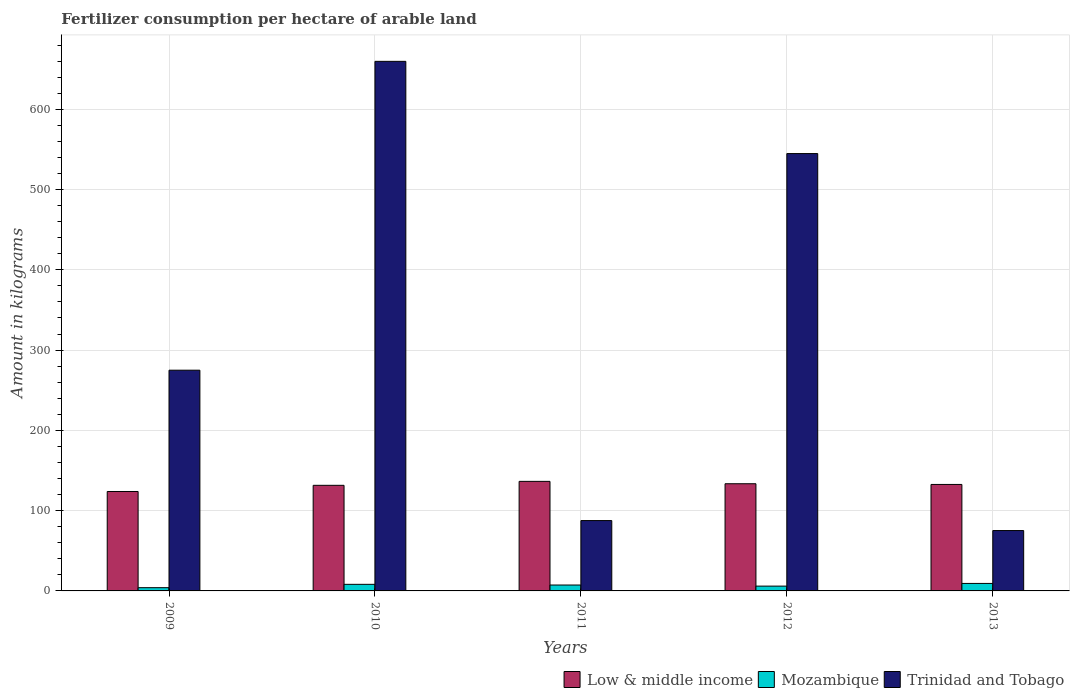How many groups of bars are there?
Provide a succinct answer. 5. Are the number of bars per tick equal to the number of legend labels?
Provide a succinct answer. Yes. Are the number of bars on each tick of the X-axis equal?
Offer a terse response. Yes. How many bars are there on the 5th tick from the left?
Give a very brief answer. 3. What is the label of the 5th group of bars from the left?
Keep it short and to the point. 2013. In how many cases, is the number of bars for a given year not equal to the number of legend labels?
Give a very brief answer. 0. What is the amount of fertilizer consumption in Mozambique in 2010?
Provide a succinct answer. 8.2. Across all years, what is the maximum amount of fertilizer consumption in Trinidad and Tobago?
Make the answer very short. 659.68. Across all years, what is the minimum amount of fertilizer consumption in Low & middle income?
Keep it short and to the point. 123.85. In which year was the amount of fertilizer consumption in Trinidad and Tobago maximum?
Your answer should be very brief. 2010. What is the total amount of fertilizer consumption in Trinidad and Tobago in the graph?
Your response must be concise. 1642.28. What is the difference between the amount of fertilizer consumption in Low & middle income in 2010 and that in 2013?
Your answer should be compact. -1.08. What is the difference between the amount of fertilizer consumption in Low & middle income in 2010 and the amount of fertilizer consumption in Trinidad and Tobago in 2013?
Your answer should be very brief. 56.35. What is the average amount of fertilizer consumption in Trinidad and Tobago per year?
Offer a very short reply. 328.46. In the year 2013, what is the difference between the amount of fertilizer consumption in Low & middle income and amount of fertilizer consumption in Mozambique?
Provide a succinct answer. 123.31. What is the ratio of the amount of fertilizer consumption in Low & middle income in 2009 to that in 2011?
Your response must be concise. 0.91. Is the amount of fertilizer consumption in Mozambique in 2009 less than that in 2012?
Provide a succinct answer. Yes. What is the difference between the highest and the second highest amount of fertilizer consumption in Low & middle income?
Offer a very short reply. 2.95. What is the difference between the highest and the lowest amount of fertilizer consumption in Low & middle income?
Your answer should be very brief. 12.62. In how many years, is the amount of fertilizer consumption in Low & middle income greater than the average amount of fertilizer consumption in Low & middle income taken over all years?
Provide a short and direct response. 3. Is the sum of the amount of fertilizer consumption in Trinidad and Tobago in 2010 and 2013 greater than the maximum amount of fertilizer consumption in Low & middle income across all years?
Your answer should be very brief. Yes. What does the 2nd bar from the left in 2012 represents?
Ensure brevity in your answer.  Mozambique. What does the 1st bar from the right in 2009 represents?
Your answer should be compact. Trinidad and Tobago. Is it the case that in every year, the sum of the amount of fertilizer consumption in Trinidad and Tobago and amount of fertilizer consumption in Low & middle income is greater than the amount of fertilizer consumption in Mozambique?
Keep it short and to the point. Yes. Are all the bars in the graph horizontal?
Offer a very short reply. No. What is the difference between two consecutive major ticks on the Y-axis?
Offer a very short reply. 100. Are the values on the major ticks of Y-axis written in scientific E-notation?
Offer a terse response. No. What is the title of the graph?
Offer a very short reply. Fertilizer consumption per hectare of arable land. Does "Australia" appear as one of the legend labels in the graph?
Provide a short and direct response. No. What is the label or title of the X-axis?
Ensure brevity in your answer.  Years. What is the label or title of the Y-axis?
Your answer should be compact. Amount in kilograms. What is the Amount in kilograms in Low & middle income in 2009?
Provide a succinct answer. 123.85. What is the Amount in kilograms of Mozambique in 2009?
Provide a succinct answer. 4.03. What is the Amount in kilograms of Trinidad and Tobago in 2009?
Give a very brief answer. 274.96. What is the Amount in kilograms in Low & middle income in 2010?
Keep it short and to the point. 131.55. What is the Amount in kilograms of Mozambique in 2010?
Provide a succinct answer. 8.2. What is the Amount in kilograms of Trinidad and Tobago in 2010?
Keep it short and to the point. 659.68. What is the Amount in kilograms in Low & middle income in 2011?
Your response must be concise. 136.47. What is the Amount in kilograms of Mozambique in 2011?
Give a very brief answer. 7.36. What is the Amount in kilograms in Trinidad and Tobago in 2011?
Offer a terse response. 87.64. What is the Amount in kilograms in Low & middle income in 2012?
Offer a terse response. 133.52. What is the Amount in kilograms of Mozambique in 2012?
Keep it short and to the point. 5.99. What is the Amount in kilograms of Trinidad and Tobago in 2012?
Offer a very short reply. 544.8. What is the Amount in kilograms of Low & middle income in 2013?
Your answer should be very brief. 132.63. What is the Amount in kilograms in Mozambique in 2013?
Your answer should be compact. 9.32. What is the Amount in kilograms of Trinidad and Tobago in 2013?
Your answer should be very brief. 75.2. Across all years, what is the maximum Amount in kilograms of Low & middle income?
Provide a short and direct response. 136.47. Across all years, what is the maximum Amount in kilograms in Mozambique?
Your answer should be compact. 9.32. Across all years, what is the maximum Amount in kilograms in Trinidad and Tobago?
Provide a short and direct response. 659.68. Across all years, what is the minimum Amount in kilograms in Low & middle income?
Your answer should be compact. 123.85. Across all years, what is the minimum Amount in kilograms in Mozambique?
Give a very brief answer. 4.03. Across all years, what is the minimum Amount in kilograms in Trinidad and Tobago?
Make the answer very short. 75.2. What is the total Amount in kilograms in Low & middle income in the graph?
Make the answer very short. 658.03. What is the total Amount in kilograms in Mozambique in the graph?
Offer a terse response. 34.91. What is the total Amount in kilograms in Trinidad and Tobago in the graph?
Ensure brevity in your answer.  1642.28. What is the difference between the Amount in kilograms in Low & middle income in 2009 and that in 2010?
Your answer should be very brief. -7.7. What is the difference between the Amount in kilograms of Mozambique in 2009 and that in 2010?
Make the answer very short. -4.17. What is the difference between the Amount in kilograms in Trinidad and Tobago in 2009 and that in 2010?
Your answer should be compact. -384.72. What is the difference between the Amount in kilograms of Low & middle income in 2009 and that in 2011?
Give a very brief answer. -12.62. What is the difference between the Amount in kilograms of Mozambique in 2009 and that in 2011?
Give a very brief answer. -3.32. What is the difference between the Amount in kilograms of Trinidad and Tobago in 2009 and that in 2011?
Offer a terse response. 187.32. What is the difference between the Amount in kilograms of Low & middle income in 2009 and that in 2012?
Provide a short and direct response. -9.66. What is the difference between the Amount in kilograms in Mozambique in 2009 and that in 2012?
Ensure brevity in your answer.  -1.96. What is the difference between the Amount in kilograms in Trinidad and Tobago in 2009 and that in 2012?
Your answer should be very brief. -269.84. What is the difference between the Amount in kilograms in Low & middle income in 2009 and that in 2013?
Your answer should be very brief. -8.78. What is the difference between the Amount in kilograms in Mozambique in 2009 and that in 2013?
Offer a terse response. -5.29. What is the difference between the Amount in kilograms of Trinidad and Tobago in 2009 and that in 2013?
Make the answer very short. 199.76. What is the difference between the Amount in kilograms of Low & middle income in 2010 and that in 2011?
Offer a terse response. -4.92. What is the difference between the Amount in kilograms of Mozambique in 2010 and that in 2011?
Provide a short and direct response. 0.84. What is the difference between the Amount in kilograms in Trinidad and Tobago in 2010 and that in 2011?
Your response must be concise. 572.04. What is the difference between the Amount in kilograms in Low & middle income in 2010 and that in 2012?
Provide a short and direct response. -1.97. What is the difference between the Amount in kilograms of Mozambique in 2010 and that in 2012?
Offer a terse response. 2.21. What is the difference between the Amount in kilograms of Trinidad and Tobago in 2010 and that in 2012?
Provide a short and direct response. 114.88. What is the difference between the Amount in kilograms in Low & middle income in 2010 and that in 2013?
Provide a succinct answer. -1.08. What is the difference between the Amount in kilograms of Mozambique in 2010 and that in 2013?
Provide a succinct answer. -1.12. What is the difference between the Amount in kilograms of Trinidad and Tobago in 2010 and that in 2013?
Your answer should be very brief. 584.48. What is the difference between the Amount in kilograms of Low & middle income in 2011 and that in 2012?
Offer a very short reply. 2.95. What is the difference between the Amount in kilograms of Mozambique in 2011 and that in 2012?
Make the answer very short. 1.36. What is the difference between the Amount in kilograms of Trinidad and Tobago in 2011 and that in 2012?
Your answer should be very brief. -457.16. What is the difference between the Amount in kilograms of Low & middle income in 2011 and that in 2013?
Provide a succinct answer. 3.84. What is the difference between the Amount in kilograms in Mozambique in 2011 and that in 2013?
Keep it short and to the point. -1.97. What is the difference between the Amount in kilograms in Trinidad and Tobago in 2011 and that in 2013?
Provide a short and direct response. 12.44. What is the difference between the Amount in kilograms of Low & middle income in 2012 and that in 2013?
Your answer should be very brief. 0.88. What is the difference between the Amount in kilograms of Mozambique in 2012 and that in 2013?
Provide a succinct answer. -3.33. What is the difference between the Amount in kilograms of Trinidad and Tobago in 2012 and that in 2013?
Your response must be concise. 469.6. What is the difference between the Amount in kilograms of Low & middle income in 2009 and the Amount in kilograms of Mozambique in 2010?
Provide a short and direct response. 115.66. What is the difference between the Amount in kilograms in Low & middle income in 2009 and the Amount in kilograms in Trinidad and Tobago in 2010?
Offer a terse response. -535.83. What is the difference between the Amount in kilograms in Mozambique in 2009 and the Amount in kilograms in Trinidad and Tobago in 2010?
Your answer should be compact. -655.65. What is the difference between the Amount in kilograms in Low & middle income in 2009 and the Amount in kilograms in Mozambique in 2011?
Keep it short and to the point. 116.5. What is the difference between the Amount in kilograms in Low & middle income in 2009 and the Amount in kilograms in Trinidad and Tobago in 2011?
Provide a succinct answer. 36.21. What is the difference between the Amount in kilograms of Mozambique in 2009 and the Amount in kilograms of Trinidad and Tobago in 2011?
Keep it short and to the point. -83.61. What is the difference between the Amount in kilograms in Low & middle income in 2009 and the Amount in kilograms in Mozambique in 2012?
Offer a very short reply. 117.86. What is the difference between the Amount in kilograms of Low & middle income in 2009 and the Amount in kilograms of Trinidad and Tobago in 2012?
Offer a very short reply. -420.95. What is the difference between the Amount in kilograms of Mozambique in 2009 and the Amount in kilograms of Trinidad and Tobago in 2012?
Make the answer very short. -540.77. What is the difference between the Amount in kilograms in Low & middle income in 2009 and the Amount in kilograms in Mozambique in 2013?
Provide a succinct answer. 114.53. What is the difference between the Amount in kilograms in Low & middle income in 2009 and the Amount in kilograms in Trinidad and Tobago in 2013?
Provide a succinct answer. 48.65. What is the difference between the Amount in kilograms of Mozambique in 2009 and the Amount in kilograms of Trinidad and Tobago in 2013?
Offer a terse response. -71.17. What is the difference between the Amount in kilograms in Low & middle income in 2010 and the Amount in kilograms in Mozambique in 2011?
Offer a terse response. 124.19. What is the difference between the Amount in kilograms in Low & middle income in 2010 and the Amount in kilograms in Trinidad and Tobago in 2011?
Offer a very short reply. 43.91. What is the difference between the Amount in kilograms of Mozambique in 2010 and the Amount in kilograms of Trinidad and Tobago in 2011?
Your response must be concise. -79.44. What is the difference between the Amount in kilograms in Low & middle income in 2010 and the Amount in kilograms in Mozambique in 2012?
Your answer should be compact. 125.56. What is the difference between the Amount in kilograms of Low & middle income in 2010 and the Amount in kilograms of Trinidad and Tobago in 2012?
Provide a succinct answer. -413.25. What is the difference between the Amount in kilograms in Mozambique in 2010 and the Amount in kilograms in Trinidad and Tobago in 2012?
Give a very brief answer. -536.6. What is the difference between the Amount in kilograms of Low & middle income in 2010 and the Amount in kilograms of Mozambique in 2013?
Keep it short and to the point. 122.23. What is the difference between the Amount in kilograms of Low & middle income in 2010 and the Amount in kilograms of Trinidad and Tobago in 2013?
Give a very brief answer. 56.35. What is the difference between the Amount in kilograms in Mozambique in 2010 and the Amount in kilograms in Trinidad and Tobago in 2013?
Make the answer very short. -67. What is the difference between the Amount in kilograms of Low & middle income in 2011 and the Amount in kilograms of Mozambique in 2012?
Ensure brevity in your answer.  130.48. What is the difference between the Amount in kilograms of Low & middle income in 2011 and the Amount in kilograms of Trinidad and Tobago in 2012?
Provide a short and direct response. -408.33. What is the difference between the Amount in kilograms of Mozambique in 2011 and the Amount in kilograms of Trinidad and Tobago in 2012?
Make the answer very short. -537.44. What is the difference between the Amount in kilograms of Low & middle income in 2011 and the Amount in kilograms of Mozambique in 2013?
Offer a very short reply. 127.15. What is the difference between the Amount in kilograms of Low & middle income in 2011 and the Amount in kilograms of Trinidad and Tobago in 2013?
Your response must be concise. 61.27. What is the difference between the Amount in kilograms in Mozambique in 2011 and the Amount in kilograms in Trinidad and Tobago in 2013?
Offer a terse response. -67.84. What is the difference between the Amount in kilograms in Low & middle income in 2012 and the Amount in kilograms in Mozambique in 2013?
Offer a very short reply. 124.2. What is the difference between the Amount in kilograms of Low & middle income in 2012 and the Amount in kilograms of Trinidad and Tobago in 2013?
Make the answer very short. 58.32. What is the difference between the Amount in kilograms of Mozambique in 2012 and the Amount in kilograms of Trinidad and Tobago in 2013?
Make the answer very short. -69.21. What is the average Amount in kilograms in Low & middle income per year?
Keep it short and to the point. 131.61. What is the average Amount in kilograms of Mozambique per year?
Offer a terse response. 6.98. What is the average Amount in kilograms in Trinidad and Tobago per year?
Provide a short and direct response. 328.46. In the year 2009, what is the difference between the Amount in kilograms in Low & middle income and Amount in kilograms in Mozambique?
Provide a short and direct response. 119.82. In the year 2009, what is the difference between the Amount in kilograms in Low & middle income and Amount in kilograms in Trinidad and Tobago?
Ensure brevity in your answer.  -151.11. In the year 2009, what is the difference between the Amount in kilograms of Mozambique and Amount in kilograms of Trinidad and Tobago?
Your answer should be very brief. -270.93. In the year 2010, what is the difference between the Amount in kilograms of Low & middle income and Amount in kilograms of Mozambique?
Ensure brevity in your answer.  123.35. In the year 2010, what is the difference between the Amount in kilograms in Low & middle income and Amount in kilograms in Trinidad and Tobago?
Your response must be concise. -528.13. In the year 2010, what is the difference between the Amount in kilograms in Mozambique and Amount in kilograms in Trinidad and Tobago?
Provide a succinct answer. -651.48. In the year 2011, what is the difference between the Amount in kilograms in Low & middle income and Amount in kilograms in Mozambique?
Give a very brief answer. 129.12. In the year 2011, what is the difference between the Amount in kilograms of Low & middle income and Amount in kilograms of Trinidad and Tobago?
Your response must be concise. 48.83. In the year 2011, what is the difference between the Amount in kilograms of Mozambique and Amount in kilograms of Trinidad and Tobago?
Provide a short and direct response. -80.28. In the year 2012, what is the difference between the Amount in kilograms of Low & middle income and Amount in kilograms of Mozambique?
Your answer should be very brief. 127.53. In the year 2012, what is the difference between the Amount in kilograms of Low & middle income and Amount in kilograms of Trinidad and Tobago?
Keep it short and to the point. -411.28. In the year 2012, what is the difference between the Amount in kilograms in Mozambique and Amount in kilograms in Trinidad and Tobago?
Keep it short and to the point. -538.81. In the year 2013, what is the difference between the Amount in kilograms in Low & middle income and Amount in kilograms in Mozambique?
Your answer should be compact. 123.31. In the year 2013, what is the difference between the Amount in kilograms in Low & middle income and Amount in kilograms in Trinidad and Tobago?
Offer a very short reply. 57.43. In the year 2013, what is the difference between the Amount in kilograms of Mozambique and Amount in kilograms of Trinidad and Tobago?
Offer a terse response. -65.88. What is the ratio of the Amount in kilograms in Low & middle income in 2009 to that in 2010?
Your response must be concise. 0.94. What is the ratio of the Amount in kilograms of Mozambique in 2009 to that in 2010?
Ensure brevity in your answer.  0.49. What is the ratio of the Amount in kilograms in Trinidad and Tobago in 2009 to that in 2010?
Your response must be concise. 0.42. What is the ratio of the Amount in kilograms in Low & middle income in 2009 to that in 2011?
Ensure brevity in your answer.  0.91. What is the ratio of the Amount in kilograms of Mozambique in 2009 to that in 2011?
Provide a succinct answer. 0.55. What is the ratio of the Amount in kilograms in Trinidad and Tobago in 2009 to that in 2011?
Make the answer very short. 3.14. What is the ratio of the Amount in kilograms of Low & middle income in 2009 to that in 2012?
Provide a short and direct response. 0.93. What is the ratio of the Amount in kilograms of Mozambique in 2009 to that in 2012?
Your answer should be very brief. 0.67. What is the ratio of the Amount in kilograms of Trinidad and Tobago in 2009 to that in 2012?
Your answer should be very brief. 0.5. What is the ratio of the Amount in kilograms of Low & middle income in 2009 to that in 2013?
Offer a very short reply. 0.93. What is the ratio of the Amount in kilograms in Mozambique in 2009 to that in 2013?
Your answer should be very brief. 0.43. What is the ratio of the Amount in kilograms in Trinidad and Tobago in 2009 to that in 2013?
Offer a terse response. 3.66. What is the ratio of the Amount in kilograms in Low & middle income in 2010 to that in 2011?
Your response must be concise. 0.96. What is the ratio of the Amount in kilograms in Mozambique in 2010 to that in 2011?
Your answer should be compact. 1.11. What is the ratio of the Amount in kilograms of Trinidad and Tobago in 2010 to that in 2011?
Your answer should be very brief. 7.53. What is the ratio of the Amount in kilograms in Mozambique in 2010 to that in 2012?
Make the answer very short. 1.37. What is the ratio of the Amount in kilograms in Trinidad and Tobago in 2010 to that in 2012?
Keep it short and to the point. 1.21. What is the ratio of the Amount in kilograms in Mozambique in 2010 to that in 2013?
Provide a succinct answer. 0.88. What is the ratio of the Amount in kilograms in Trinidad and Tobago in 2010 to that in 2013?
Ensure brevity in your answer.  8.77. What is the ratio of the Amount in kilograms of Low & middle income in 2011 to that in 2012?
Make the answer very short. 1.02. What is the ratio of the Amount in kilograms of Mozambique in 2011 to that in 2012?
Make the answer very short. 1.23. What is the ratio of the Amount in kilograms of Trinidad and Tobago in 2011 to that in 2012?
Your response must be concise. 0.16. What is the ratio of the Amount in kilograms of Low & middle income in 2011 to that in 2013?
Your answer should be very brief. 1.03. What is the ratio of the Amount in kilograms of Mozambique in 2011 to that in 2013?
Offer a terse response. 0.79. What is the ratio of the Amount in kilograms of Trinidad and Tobago in 2011 to that in 2013?
Your answer should be compact. 1.17. What is the ratio of the Amount in kilograms in Mozambique in 2012 to that in 2013?
Provide a succinct answer. 0.64. What is the ratio of the Amount in kilograms in Trinidad and Tobago in 2012 to that in 2013?
Your answer should be compact. 7.24. What is the difference between the highest and the second highest Amount in kilograms in Low & middle income?
Your response must be concise. 2.95. What is the difference between the highest and the second highest Amount in kilograms in Mozambique?
Keep it short and to the point. 1.12. What is the difference between the highest and the second highest Amount in kilograms of Trinidad and Tobago?
Make the answer very short. 114.88. What is the difference between the highest and the lowest Amount in kilograms in Low & middle income?
Provide a succinct answer. 12.62. What is the difference between the highest and the lowest Amount in kilograms in Mozambique?
Your response must be concise. 5.29. What is the difference between the highest and the lowest Amount in kilograms of Trinidad and Tobago?
Make the answer very short. 584.48. 